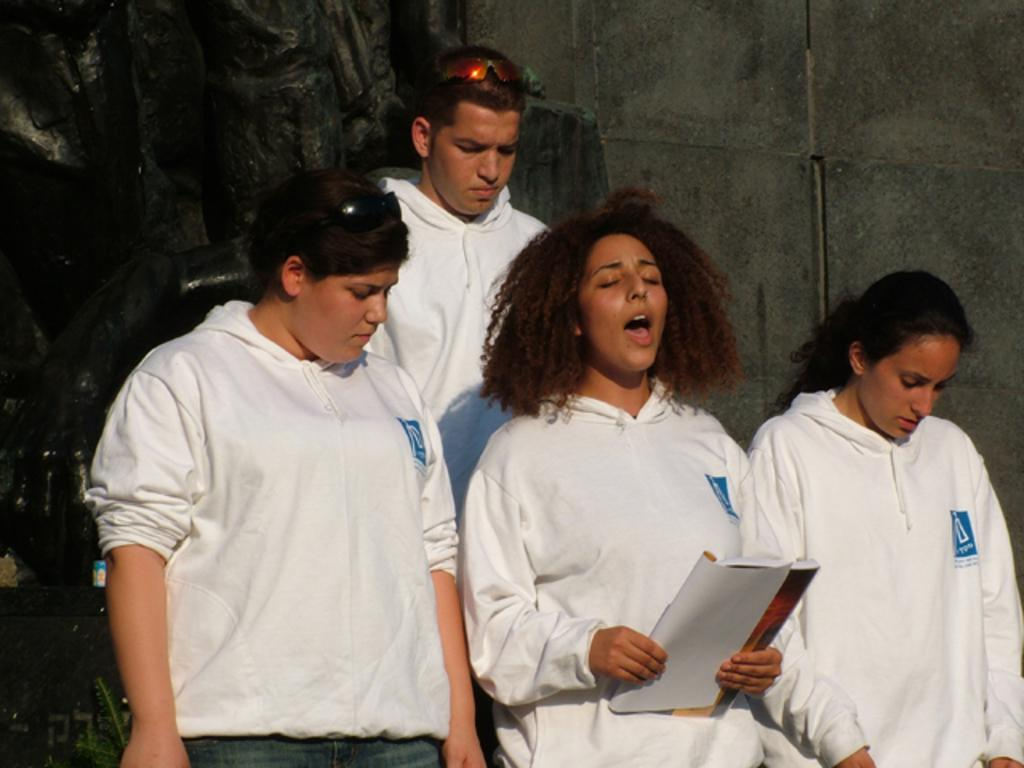How many people are present in the image? There are four people standing in the image. What is one person holding in the image? One person is holding a book. What can be seen in the background of the image? There is a wall visible in the image. What type of popcorn is being shared by the beggar in the image? There is no popcorn or beggar present in the image. Is there a bomb visible in the image? No, there is no bomb visible in the image. 